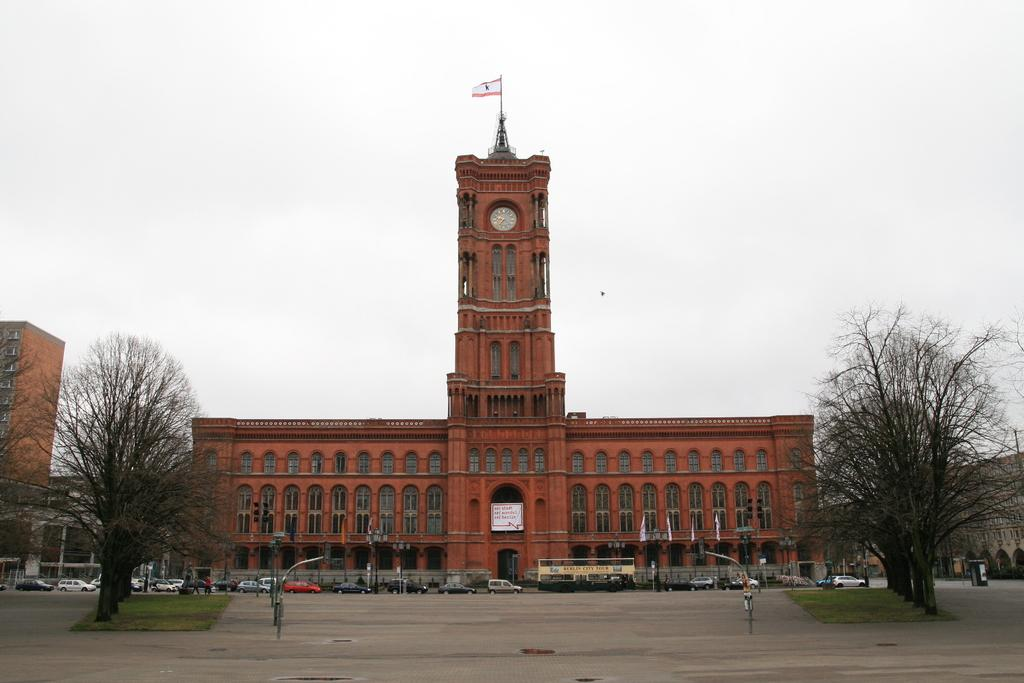What type of vegetation can be seen in the image? There are trees in the image. What structures are present in the image? There are poles and a building in the image. What can be seen attached to the poles and building? There are flags in the image. What is happening on the road in the image? There are vehicles on the road in the image. Where is another flag located in the image? There is a flag on a building in the image. What architectural features can be seen in the image? There are windows in the image. What time-related object is present in the image? There is a clock on the wall in the image. What type of container is in the image? There is a bin in the image. What is on the wall in the image? There is a board on the wall in the image. What part of the natural environment is visible in the image? The sky is visible in the image. What type of flower can be seen growing on the road in the image? There are no flowers visible on the road in the image. What type of butter is being used to hold the flags in place in the image? There is no butter present in the image; the flags are attached to poles and a building. 